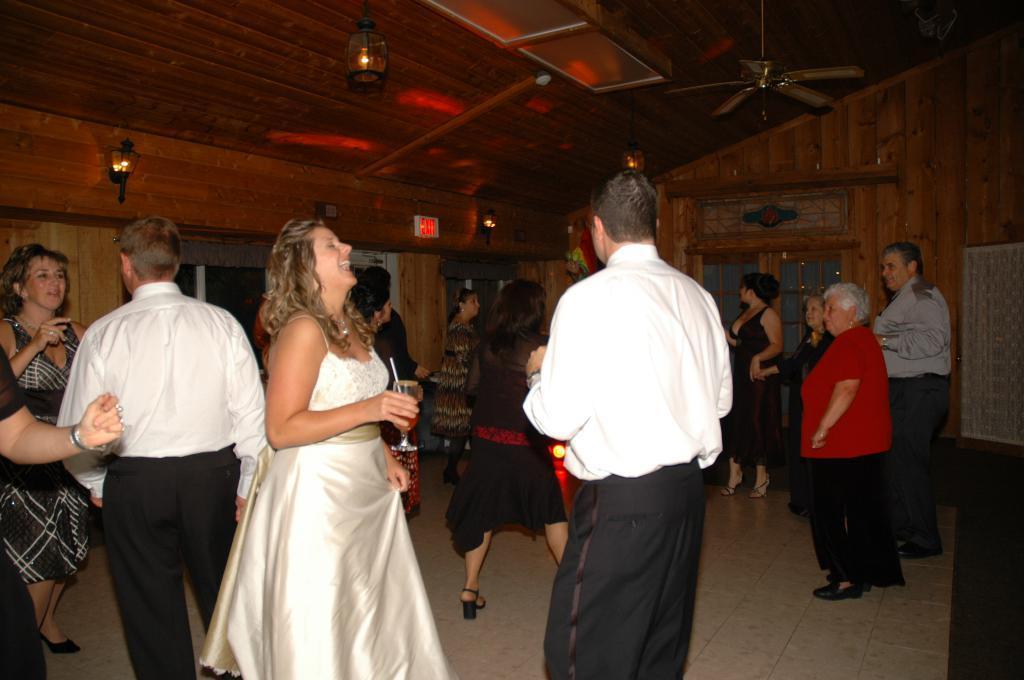Please provide a concise description of this image. In this image, I can see a group of people standing on the floor. At the top of the image, I can see the lamps and a ceiling fan hanging to the ceiling. In the background, there are windows and lamps attached to the wooden wall. On the right side of the image, I can see an object. 